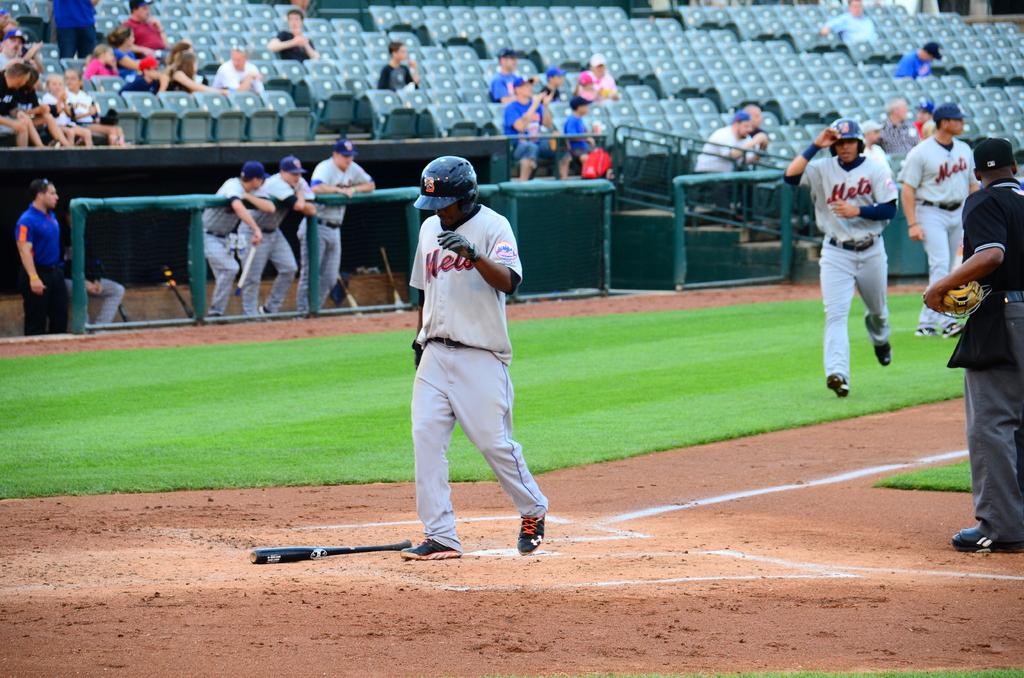What team name is written in red letters?
Keep it short and to the point. Mets. 